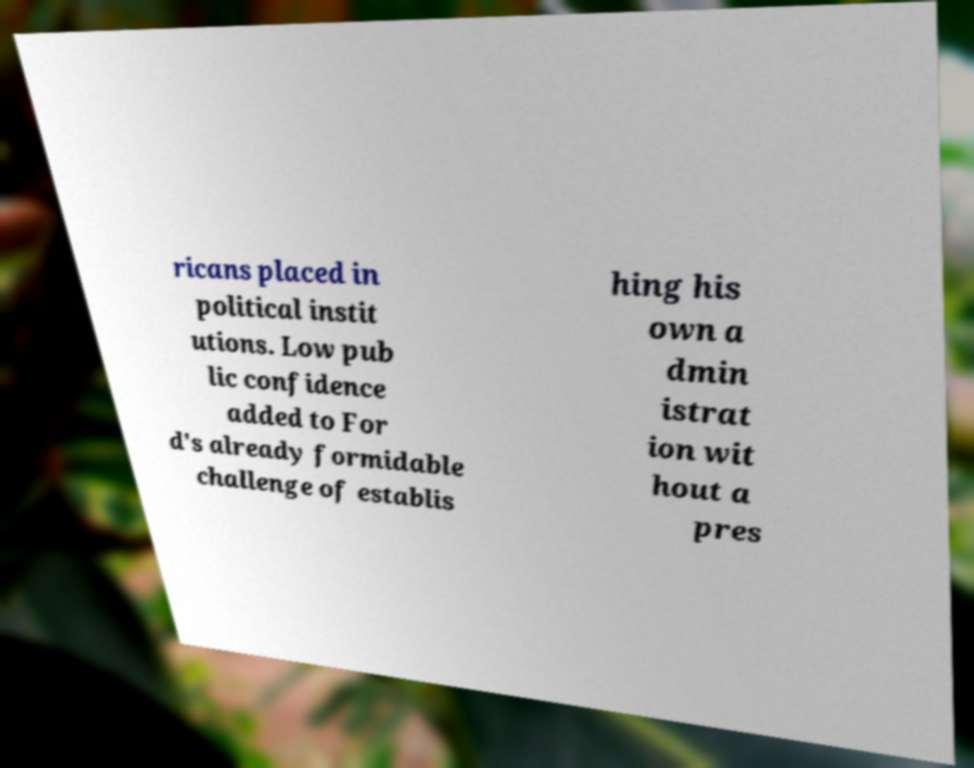Please read and relay the text visible in this image. What does it say? ricans placed in political instit utions. Low pub lic confidence added to For d's already formidable challenge of establis hing his own a dmin istrat ion wit hout a pres 